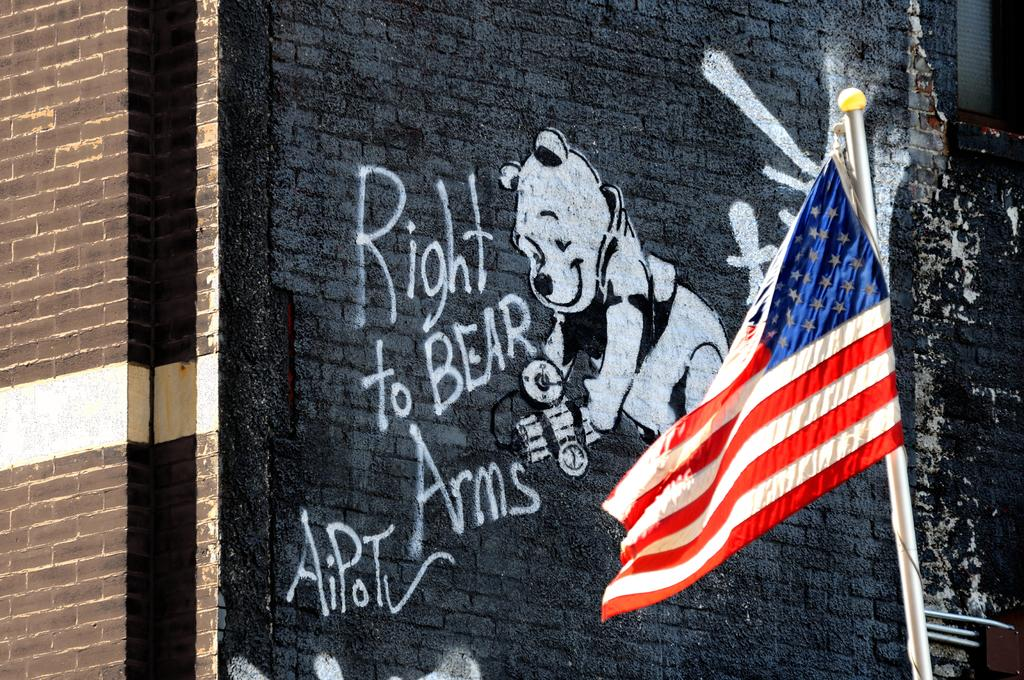What is attached to the pole in the image? There is a flag attached to the pole in the image. What can be seen on the wall of a building in the image? There is graffiti on the wall of a building in the image. What type of seed can be seen growing out of the flagpole in the image? There is no seed growing out of the flagpole in the image; it only features a flag attached to a pole. What is the cause of the wound on the wall of the building in the image? There is no wound present on the wall of the building in the image; it only features graffiti. 